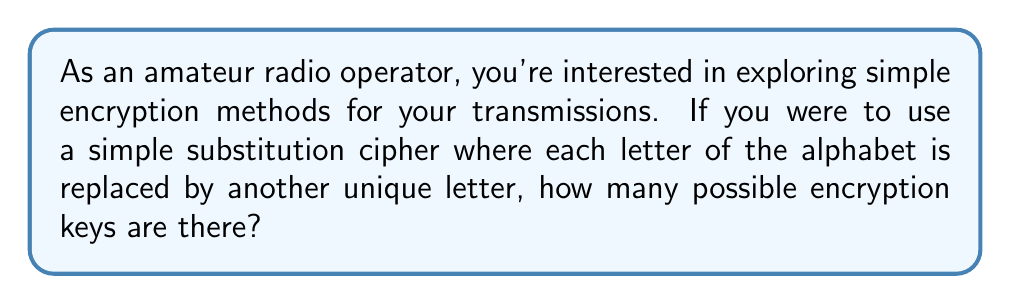Help me with this question. To solve this problem, let's follow these steps:

1) In a simple substitution cipher, each letter of the alphabet is replaced by another unique letter. This means we're dealing with a permutation of the 26 letters of the alphabet.

2) The number of ways to arrange n distinct objects is given by the factorial of n, denoted as n!

3) In this case, n = 26 (the number of letters in the English alphabet)

4) Therefore, the number of possible encryption keys is 26!

5) Let's calculate this:

   $$26! = 26 \times 25 \times 24 \times ... \times 3 \times 2 \times 1$$

6) This is a very large number. Using a calculator or computer, we can compute it:

   $$26! = 403,291,461,126,605,635,584,000,000$$

7) In scientific notation, this is approximately:

   $$26! \approx 4.03 \times 10^{26}$$

This incredibly large number illustrates why simple substitution ciphers, despite being easy to implement, can be quite secure against brute-force attacks if the message is short.
Answer: $26! \approx 4.03 \times 10^{26}$ 